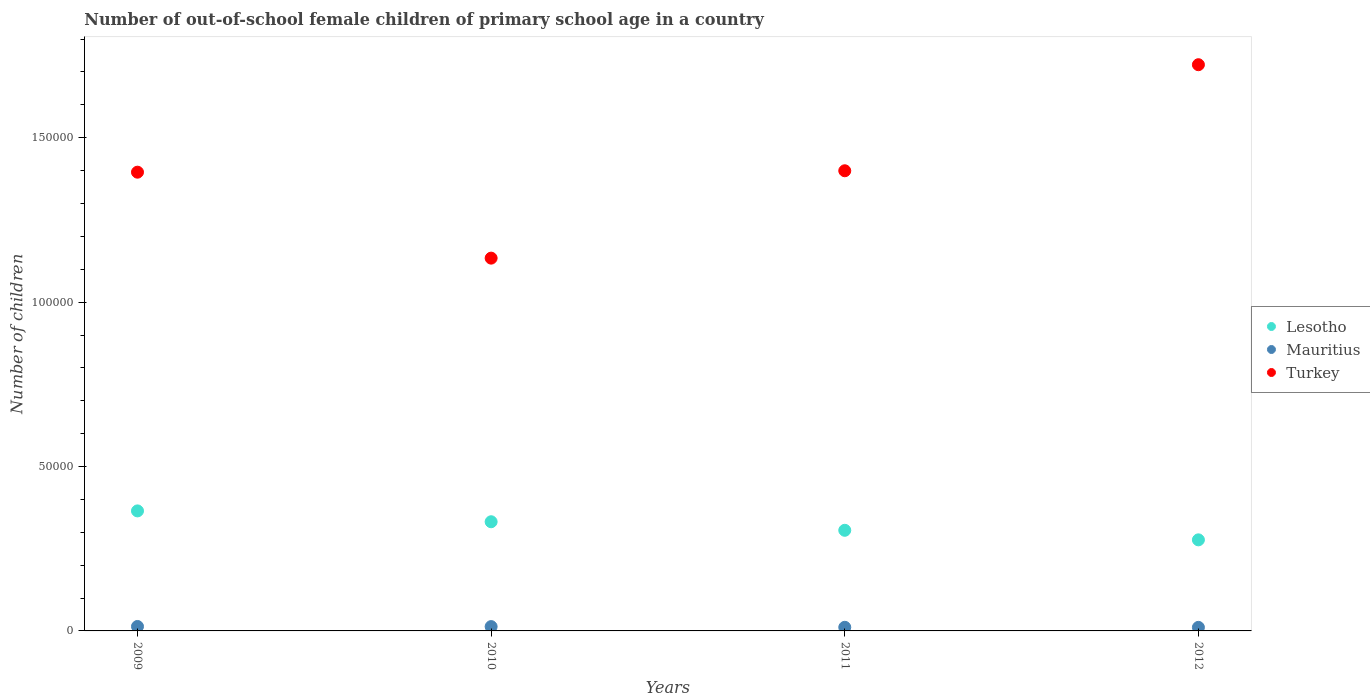What is the number of out-of-school female children in Turkey in 2011?
Give a very brief answer. 1.40e+05. Across all years, what is the maximum number of out-of-school female children in Lesotho?
Keep it short and to the point. 3.65e+04. Across all years, what is the minimum number of out-of-school female children in Mauritius?
Your response must be concise. 1081. In which year was the number of out-of-school female children in Lesotho maximum?
Your response must be concise. 2009. What is the total number of out-of-school female children in Turkey in the graph?
Offer a very short reply. 5.65e+05. What is the difference between the number of out-of-school female children in Lesotho in 2010 and that in 2012?
Your answer should be compact. 5504. What is the difference between the number of out-of-school female children in Turkey in 2010 and the number of out-of-school female children in Mauritius in 2009?
Your response must be concise. 1.12e+05. What is the average number of out-of-school female children in Lesotho per year?
Make the answer very short. 3.20e+04. In the year 2010, what is the difference between the number of out-of-school female children in Lesotho and number of out-of-school female children in Turkey?
Make the answer very short. -8.02e+04. What is the ratio of the number of out-of-school female children in Lesotho in 2011 to that in 2012?
Give a very brief answer. 1.1. Is the number of out-of-school female children in Turkey in 2009 less than that in 2012?
Your response must be concise. Yes. What is the difference between the highest and the second highest number of out-of-school female children in Turkey?
Offer a terse response. 3.23e+04. What is the difference between the highest and the lowest number of out-of-school female children in Lesotho?
Offer a terse response. 8804. Does the number of out-of-school female children in Mauritius monotonically increase over the years?
Provide a succinct answer. No. Is the number of out-of-school female children in Turkey strictly greater than the number of out-of-school female children in Mauritius over the years?
Provide a succinct answer. Yes. Is the number of out-of-school female children in Turkey strictly less than the number of out-of-school female children in Lesotho over the years?
Give a very brief answer. No. Are the values on the major ticks of Y-axis written in scientific E-notation?
Ensure brevity in your answer.  No. Does the graph contain any zero values?
Your response must be concise. No. Does the graph contain grids?
Offer a terse response. No. Where does the legend appear in the graph?
Offer a terse response. Center right. What is the title of the graph?
Ensure brevity in your answer.  Number of out-of-school female children of primary school age in a country. What is the label or title of the X-axis?
Offer a very short reply. Years. What is the label or title of the Y-axis?
Provide a short and direct response. Number of children. What is the Number of children of Lesotho in 2009?
Offer a terse response. 3.65e+04. What is the Number of children in Mauritius in 2009?
Give a very brief answer. 1351. What is the Number of children of Turkey in 2009?
Provide a short and direct response. 1.40e+05. What is the Number of children of Lesotho in 2010?
Offer a very short reply. 3.32e+04. What is the Number of children of Mauritius in 2010?
Provide a succinct answer. 1316. What is the Number of children in Turkey in 2010?
Your answer should be very brief. 1.13e+05. What is the Number of children in Lesotho in 2011?
Ensure brevity in your answer.  3.06e+04. What is the Number of children of Mauritius in 2011?
Make the answer very short. 1100. What is the Number of children in Turkey in 2011?
Your response must be concise. 1.40e+05. What is the Number of children of Lesotho in 2012?
Provide a succinct answer. 2.77e+04. What is the Number of children in Mauritius in 2012?
Provide a succinct answer. 1081. What is the Number of children of Turkey in 2012?
Offer a terse response. 1.72e+05. Across all years, what is the maximum Number of children in Lesotho?
Your response must be concise. 3.65e+04. Across all years, what is the maximum Number of children in Mauritius?
Ensure brevity in your answer.  1351. Across all years, what is the maximum Number of children in Turkey?
Keep it short and to the point. 1.72e+05. Across all years, what is the minimum Number of children in Lesotho?
Keep it short and to the point. 2.77e+04. Across all years, what is the minimum Number of children in Mauritius?
Provide a short and direct response. 1081. Across all years, what is the minimum Number of children in Turkey?
Offer a terse response. 1.13e+05. What is the total Number of children of Lesotho in the graph?
Your answer should be very brief. 1.28e+05. What is the total Number of children in Mauritius in the graph?
Offer a very short reply. 4848. What is the total Number of children of Turkey in the graph?
Offer a terse response. 5.65e+05. What is the difference between the Number of children of Lesotho in 2009 and that in 2010?
Your answer should be very brief. 3300. What is the difference between the Number of children in Mauritius in 2009 and that in 2010?
Offer a very short reply. 35. What is the difference between the Number of children of Turkey in 2009 and that in 2010?
Keep it short and to the point. 2.61e+04. What is the difference between the Number of children in Lesotho in 2009 and that in 2011?
Your answer should be very brief. 5899. What is the difference between the Number of children of Mauritius in 2009 and that in 2011?
Ensure brevity in your answer.  251. What is the difference between the Number of children in Turkey in 2009 and that in 2011?
Offer a very short reply. -429. What is the difference between the Number of children in Lesotho in 2009 and that in 2012?
Give a very brief answer. 8804. What is the difference between the Number of children of Mauritius in 2009 and that in 2012?
Make the answer very short. 270. What is the difference between the Number of children of Turkey in 2009 and that in 2012?
Provide a succinct answer. -3.27e+04. What is the difference between the Number of children in Lesotho in 2010 and that in 2011?
Make the answer very short. 2599. What is the difference between the Number of children of Mauritius in 2010 and that in 2011?
Provide a short and direct response. 216. What is the difference between the Number of children of Turkey in 2010 and that in 2011?
Ensure brevity in your answer.  -2.66e+04. What is the difference between the Number of children in Lesotho in 2010 and that in 2012?
Give a very brief answer. 5504. What is the difference between the Number of children in Mauritius in 2010 and that in 2012?
Offer a terse response. 235. What is the difference between the Number of children of Turkey in 2010 and that in 2012?
Provide a short and direct response. -5.88e+04. What is the difference between the Number of children of Lesotho in 2011 and that in 2012?
Give a very brief answer. 2905. What is the difference between the Number of children in Turkey in 2011 and that in 2012?
Ensure brevity in your answer.  -3.23e+04. What is the difference between the Number of children in Lesotho in 2009 and the Number of children in Mauritius in 2010?
Make the answer very short. 3.52e+04. What is the difference between the Number of children in Lesotho in 2009 and the Number of children in Turkey in 2010?
Provide a succinct answer. -7.69e+04. What is the difference between the Number of children of Mauritius in 2009 and the Number of children of Turkey in 2010?
Your response must be concise. -1.12e+05. What is the difference between the Number of children in Lesotho in 2009 and the Number of children in Mauritius in 2011?
Give a very brief answer. 3.54e+04. What is the difference between the Number of children in Lesotho in 2009 and the Number of children in Turkey in 2011?
Provide a succinct answer. -1.03e+05. What is the difference between the Number of children in Mauritius in 2009 and the Number of children in Turkey in 2011?
Provide a succinct answer. -1.39e+05. What is the difference between the Number of children of Lesotho in 2009 and the Number of children of Mauritius in 2012?
Provide a succinct answer. 3.54e+04. What is the difference between the Number of children in Lesotho in 2009 and the Number of children in Turkey in 2012?
Make the answer very short. -1.36e+05. What is the difference between the Number of children of Mauritius in 2009 and the Number of children of Turkey in 2012?
Keep it short and to the point. -1.71e+05. What is the difference between the Number of children of Lesotho in 2010 and the Number of children of Mauritius in 2011?
Offer a terse response. 3.21e+04. What is the difference between the Number of children of Lesotho in 2010 and the Number of children of Turkey in 2011?
Provide a succinct answer. -1.07e+05. What is the difference between the Number of children in Mauritius in 2010 and the Number of children in Turkey in 2011?
Provide a succinct answer. -1.39e+05. What is the difference between the Number of children in Lesotho in 2010 and the Number of children in Mauritius in 2012?
Your response must be concise. 3.21e+04. What is the difference between the Number of children of Lesotho in 2010 and the Number of children of Turkey in 2012?
Provide a short and direct response. -1.39e+05. What is the difference between the Number of children in Mauritius in 2010 and the Number of children in Turkey in 2012?
Keep it short and to the point. -1.71e+05. What is the difference between the Number of children of Lesotho in 2011 and the Number of children of Mauritius in 2012?
Make the answer very short. 2.95e+04. What is the difference between the Number of children of Lesotho in 2011 and the Number of children of Turkey in 2012?
Provide a succinct answer. -1.42e+05. What is the difference between the Number of children of Mauritius in 2011 and the Number of children of Turkey in 2012?
Your answer should be very brief. -1.71e+05. What is the average Number of children in Lesotho per year?
Provide a short and direct response. 3.20e+04. What is the average Number of children in Mauritius per year?
Offer a terse response. 1212. What is the average Number of children in Turkey per year?
Your response must be concise. 1.41e+05. In the year 2009, what is the difference between the Number of children in Lesotho and Number of children in Mauritius?
Provide a succinct answer. 3.52e+04. In the year 2009, what is the difference between the Number of children of Lesotho and Number of children of Turkey?
Your answer should be very brief. -1.03e+05. In the year 2009, what is the difference between the Number of children in Mauritius and Number of children in Turkey?
Keep it short and to the point. -1.38e+05. In the year 2010, what is the difference between the Number of children in Lesotho and Number of children in Mauritius?
Ensure brevity in your answer.  3.19e+04. In the year 2010, what is the difference between the Number of children of Lesotho and Number of children of Turkey?
Offer a terse response. -8.02e+04. In the year 2010, what is the difference between the Number of children of Mauritius and Number of children of Turkey?
Your response must be concise. -1.12e+05. In the year 2011, what is the difference between the Number of children in Lesotho and Number of children in Mauritius?
Ensure brevity in your answer.  2.95e+04. In the year 2011, what is the difference between the Number of children in Lesotho and Number of children in Turkey?
Your response must be concise. -1.09e+05. In the year 2011, what is the difference between the Number of children of Mauritius and Number of children of Turkey?
Provide a short and direct response. -1.39e+05. In the year 2012, what is the difference between the Number of children of Lesotho and Number of children of Mauritius?
Make the answer very short. 2.66e+04. In the year 2012, what is the difference between the Number of children of Lesotho and Number of children of Turkey?
Provide a succinct answer. -1.45e+05. In the year 2012, what is the difference between the Number of children of Mauritius and Number of children of Turkey?
Ensure brevity in your answer.  -1.71e+05. What is the ratio of the Number of children in Lesotho in 2009 to that in 2010?
Make the answer very short. 1.1. What is the ratio of the Number of children in Mauritius in 2009 to that in 2010?
Provide a succinct answer. 1.03. What is the ratio of the Number of children of Turkey in 2009 to that in 2010?
Your response must be concise. 1.23. What is the ratio of the Number of children of Lesotho in 2009 to that in 2011?
Provide a succinct answer. 1.19. What is the ratio of the Number of children in Mauritius in 2009 to that in 2011?
Make the answer very short. 1.23. What is the ratio of the Number of children in Turkey in 2009 to that in 2011?
Provide a short and direct response. 1. What is the ratio of the Number of children in Lesotho in 2009 to that in 2012?
Offer a very short reply. 1.32. What is the ratio of the Number of children in Mauritius in 2009 to that in 2012?
Offer a terse response. 1.25. What is the ratio of the Number of children of Turkey in 2009 to that in 2012?
Give a very brief answer. 0.81. What is the ratio of the Number of children in Lesotho in 2010 to that in 2011?
Give a very brief answer. 1.08. What is the ratio of the Number of children of Mauritius in 2010 to that in 2011?
Give a very brief answer. 1.2. What is the ratio of the Number of children of Turkey in 2010 to that in 2011?
Make the answer very short. 0.81. What is the ratio of the Number of children of Lesotho in 2010 to that in 2012?
Provide a short and direct response. 1.2. What is the ratio of the Number of children of Mauritius in 2010 to that in 2012?
Offer a very short reply. 1.22. What is the ratio of the Number of children in Turkey in 2010 to that in 2012?
Your response must be concise. 0.66. What is the ratio of the Number of children in Lesotho in 2011 to that in 2012?
Offer a terse response. 1.1. What is the ratio of the Number of children in Mauritius in 2011 to that in 2012?
Your answer should be very brief. 1.02. What is the ratio of the Number of children of Turkey in 2011 to that in 2012?
Provide a succinct answer. 0.81. What is the difference between the highest and the second highest Number of children in Lesotho?
Your response must be concise. 3300. What is the difference between the highest and the second highest Number of children in Mauritius?
Offer a very short reply. 35. What is the difference between the highest and the second highest Number of children in Turkey?
Provide a short and direct response. 3.23e+04. What is the difference between the highest and the lowest Number of children of Lesotho?
Offer a terse response. 8804. What is the difference between the highest and the lowest Number of children in Mauritius?
Provide a succinct answer. 270. What is the difference between the highest and the lowest Number of children of Turkey?
Offer a terse response. 5.88e+04. 